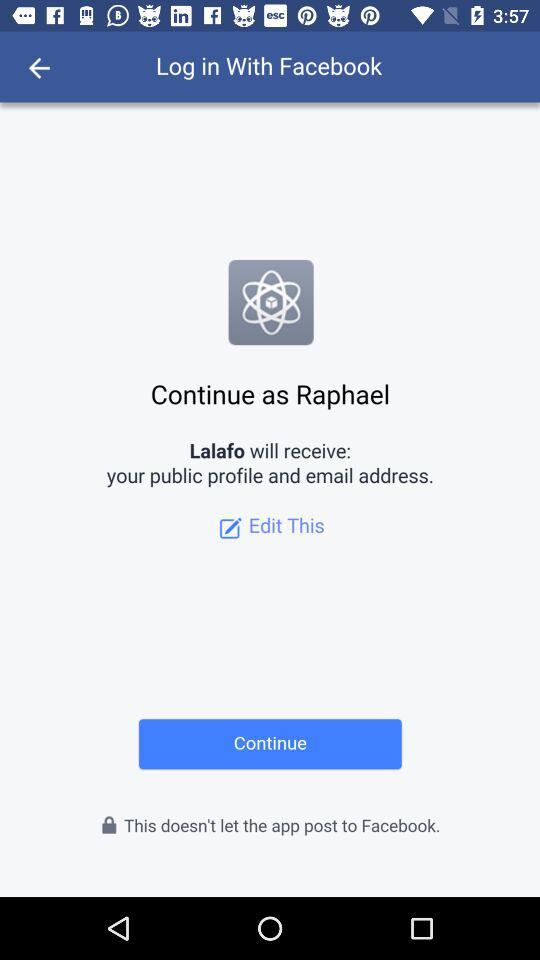Which option is selected?
When the provided information is insufficient, respond with <no answer>. <no answer> 